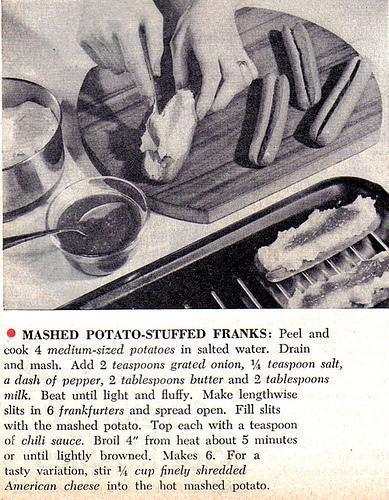How many franks does the recipe make?
Give a very brief answer. 6. How many stuffed buns are on the cutting board?
Give a very brief answer. 1. How many hot dogs are on the cutting board?
Give a very brief answer. 3. How many hands are near the hot dogs?
Give a very brief answer. 2. 